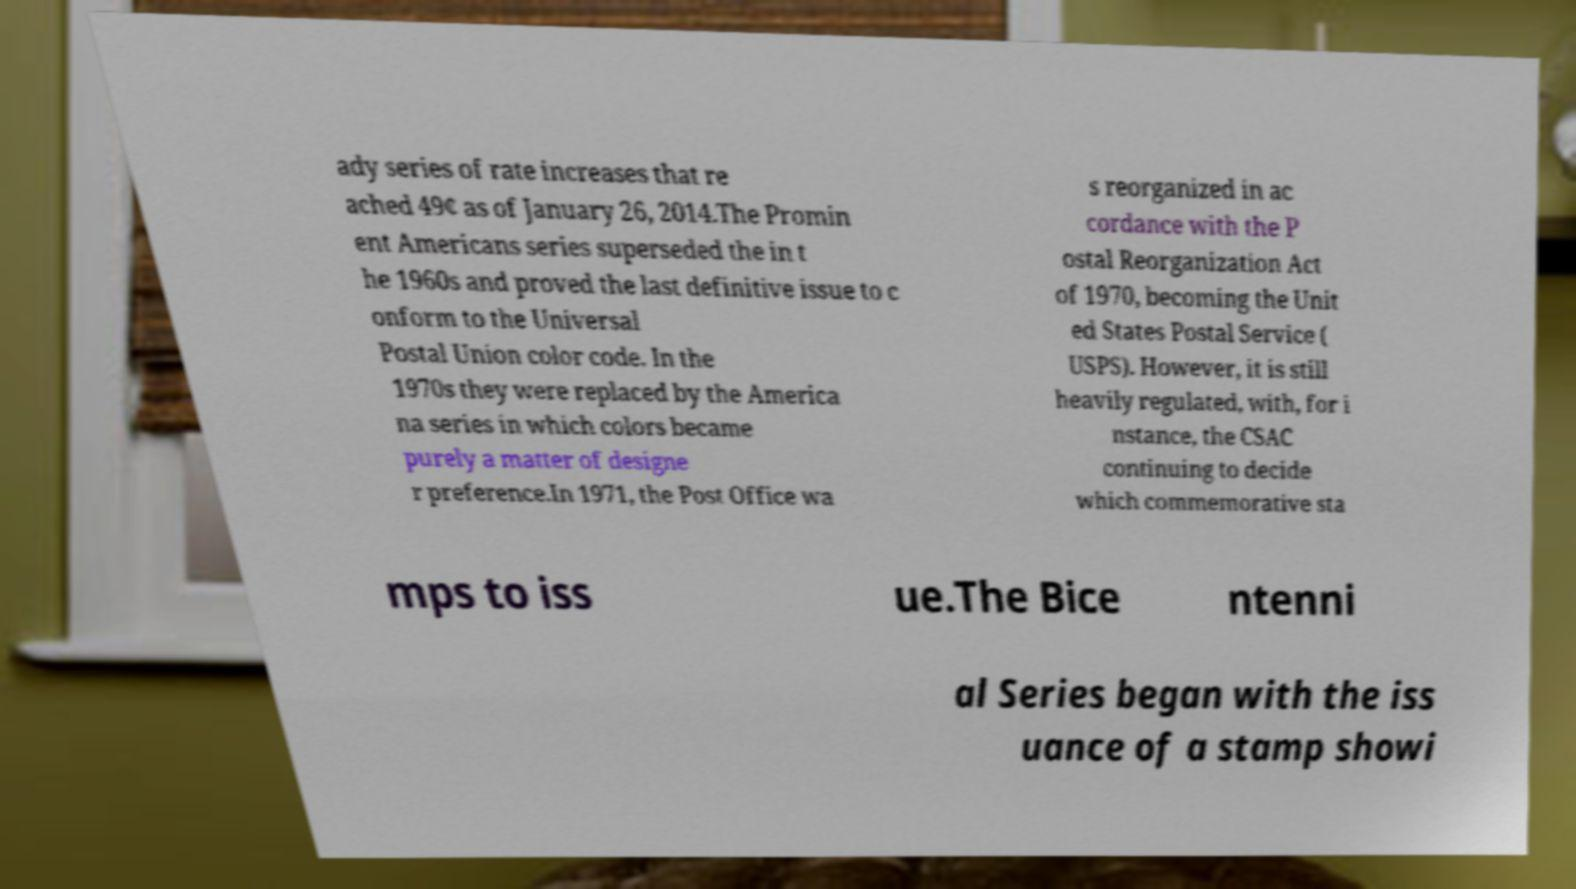I need the written content from this picture converted into text. Can you do that? ady series of rate increases that re ached 49¢ as of January 26, 2014.The Promin ent Americans series superseded the in t he 1960s and proved the last definitive issue to c onform to the Universal Postal Union color code. In the 1970s they were replaced by the America na series in which colors became purely a matter of designe r preference.In 1971, the Post Office wa s reorganized in ac cordance with the P ostal Reorganization Act of 1970, becoming the Unit ed States Postal Service ( USPS). However, it is still heavily regulated, with, for i nstance, the CSAC continuing to decide which commemorative sta mps to iss ue.The Bice ntenni al Series began with the iss uance of a stamp showi 